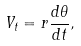Convert formula to latex. <formula><loc_0><loc_0><loc_500><loc_500>V _ { t } = r \frac { d \theta } { d t } ,</formula> 